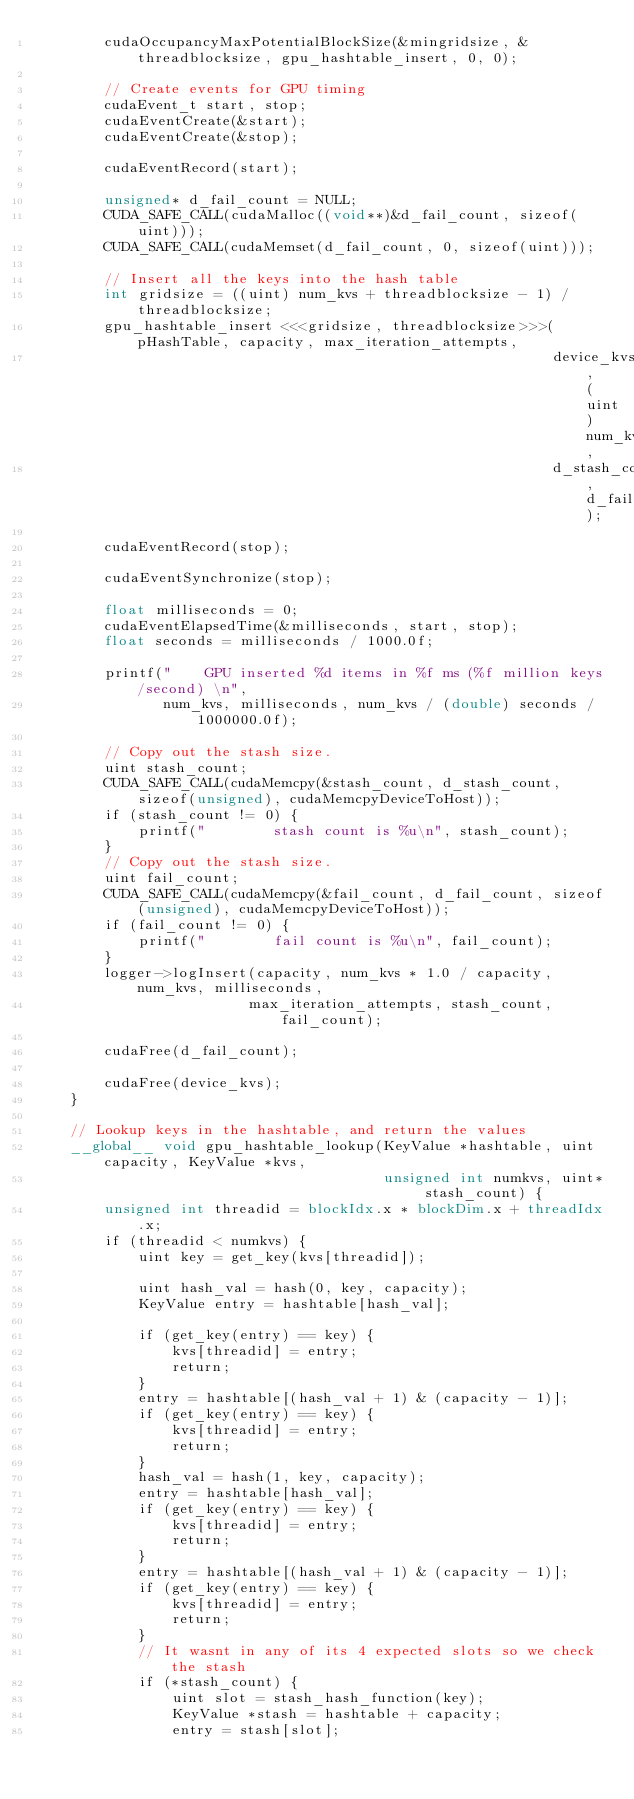<code> <loc_0><loc_0><loc_500><loc_500><_Cuda_>        cudaOccupancyMaxPotentialBlockSize(&mingridsize, &threadblocksize, gpu_hashtable_insert, 0, 0);

        // Create events for GPU timing
        cudaEvent_t start, stop;
        cudaEventCreate(&start);
        cudaEventCreate(&stop);

        cudaEventRecord(start);

        unsigned* d_fail_count = NULL;
        CUDA_SAFE_CALL(cudaMalloc((void**)&d_fail_count, sizeof(uint)));
        CUDA_SAFE_CALL(cudaMemset(d_fail_count, 0, sizeof(uint)));

        // Insert all the keys into the hash table
        int gridsize = ((uint) num_kvs + threadblocksize - 1) / threadblocksize;
        gpu_hashtable_insert <<<gridsize, threadblocksize>>>(pHashTable, capacity, max_iteration_attempts,
                                                             device_kvs, (uint) num_kvs,
                                                             d_stash_count, d_fail_count);

        cudaEventRecord(stop);

        cudaEventSynchronize(stop);

        float milliseconds = 0;
        cudaEventElapsedTime(&milliseconds, start, stop);
        float seconds = milliseconds / 1000.0f;

        printf("    GPU inserted %d items in %f ms (%f million keys/second) \n",
               num_kvs, milliseconds, num_kvs / (double) seconds / 1000000.0f);

        // Copy out the stash size.
        uint stash_count;
        CUDA_SAFE_CALL(cudaMemcpy(&stash_count, d_stash_count, sizeof(unsigned), cudaMemcpyDeviceToHost));
        if (stash_count != 0) {
            printf("        stash count is %u\n", stash_count);
        }
        // Copy out the stash size.
        uint fail_count;
        CUDA_SAFE_CALL(cudaMemcpy(&fail_count, d_fail_count, sizeof(unsigned), cudaMemcpyDeviceToHost));
        if (fail_count != 0) {
            printf("        fail count is %u\n", fail_count);
        }
        logger->logInsert(capacity, num_kvs * 1.0 / capacity, num_kvs, milliseconds,
                         max_iteration_attempts, stash_count, fail_count);

        cudaFree(d_fail_count);

        cudaFree(device_kvs);
    }

    // Lookup keys in the hashtable, and return the values
    __global__ void gpu_hashtable_lookup(KeyValue *hashtable, uint capacity, KeyValue *kvs,
                                         unsigned int numkvs, uint* stash_count) {
        unsigned int threadid = blockIdx.x * blockDim.x + threadIdx.x;
        if (threadid < numkvs) {
            uint key = get_key(kvs[threadid]);

            uint hash_val = hash(0, key, capacity);
            KeyValue entry = hashtable[hash_val];

            if (get_key(entry) == key) {
                kvs[threadid] = entry;
                return;
            }
            entry = hashtable[(hash_val + 1) & (capacity - 1)];
            if (get_key(entry) == key) {
                kvs[threadid] = entry;
                return;
            }
            hash_val = hash(1, key, capacity);
            entry = hashtable[hash_val];
            if (get_key(entry) == key) {
                kvs[threadid] = entry;
                return;
            }
            entry = hashtable[(hash_val + 1) & (capacity - 1)];
            if (get_key(entry) == key) {
                kvs[threadid] = entry;
                return;
            }
            // It wasnt in any of its 4 expected slots so we check the stash
            if (*stash_count) {
                uint slot = stash_hash_function(key);
                KeyValue *stash = hashtable + capacity;
                entry = stash[slot];</code> 